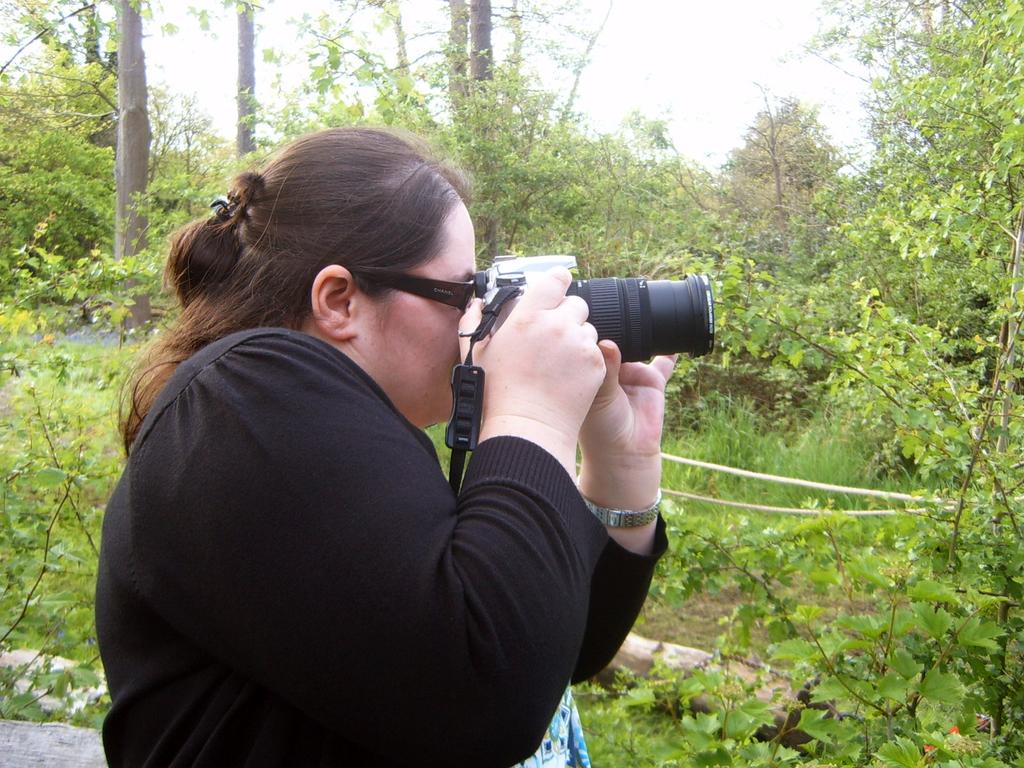Where was the image taken? The image was taken in a garden. Who is present in the camera in the image? There is a woman in the image. What is the woman doing in the image? The woman is standing and holding a camera, and she is taking a photo. What can be seen in the background of the image? There are trees and the sky visible in the background of the image. What type of surface is under the woman's feet in the image? There is grass on the floor in the image. How many bears can be seen in the image? There are no bears present in the image. What type of rose is the woman holding in the image? There is no rose present in the image; the woman is holding a camera. 